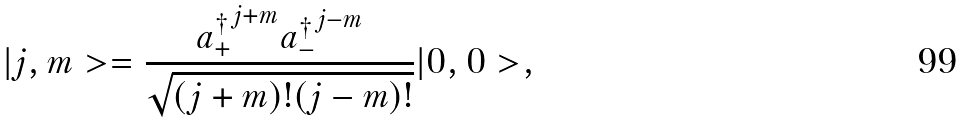Convert formula to latex. <formula><loc_0><loc_0><loc_500><loc_500>| j , m > = \frac { { a _ { + } ^ { \dagger } } ^ { j + m } { a _ { - } ^ { \dagger } } ^ { j - m } } { \sqrt { ( j + m ) ! ( j - m ) ! } } | 0 , 0 > ,</formula> 